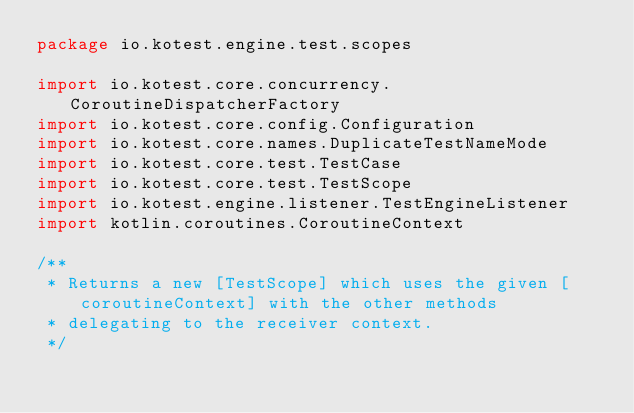<code> <loc_0><loc_0><loc_500><loc_500><_Kotlin_>package io.kotest.engine.test.scopes

import io.kotest.core.concurrency.CoroutineDispatcherFactory
import io.kotest.core.config.Configuration
import io.kotest.core.names.DuplicateTestNameMode
import io.kotest.core.test.TestCase
import io.kotest.core.test.TestScope
import io.kotest.engine.listener.TestEngineListener
import kotlin.coroutines.CoroutineContext

/**
 * Returns a new [TestScope] which uses the given [coroutineContext] with the other methods
 * delegating to the receiver context.
 */</code> 